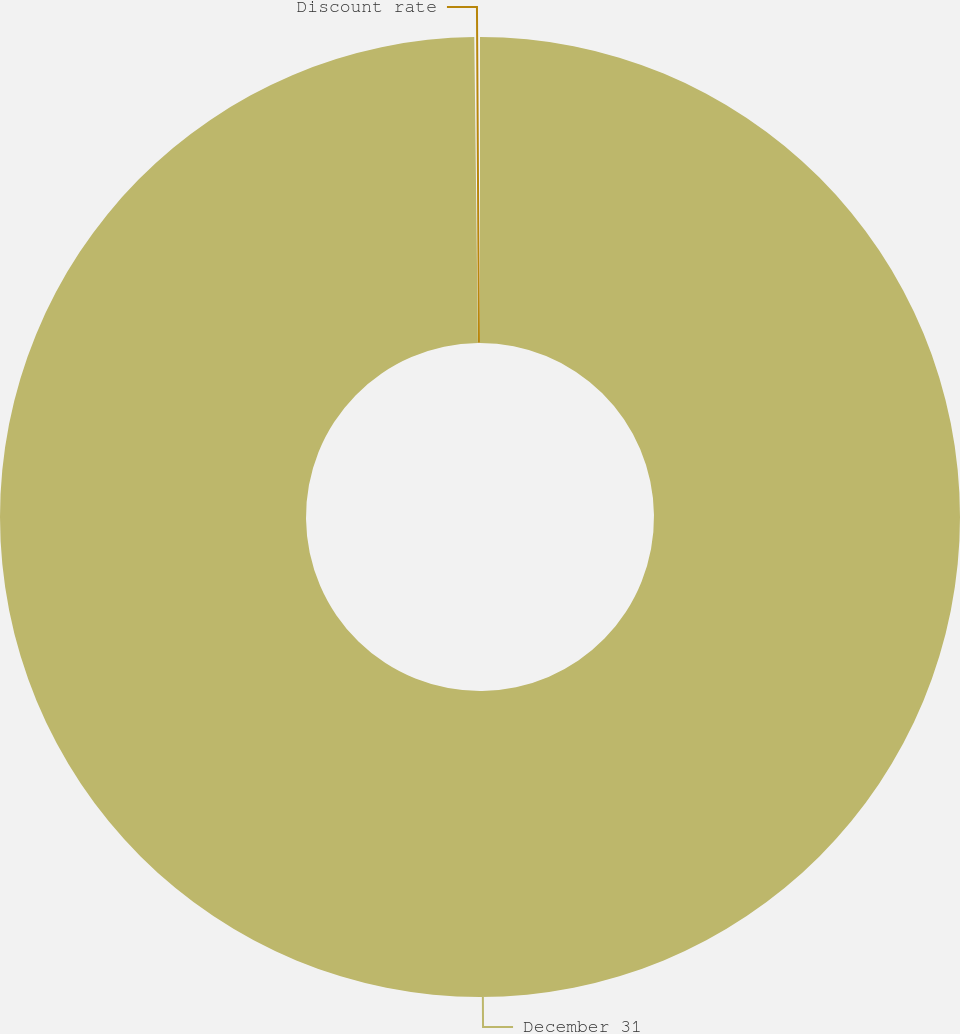<chart> <loc_0><loc_0><loc_500><loc_500><pie_chart><fcel>December 31<fcel>Discount rate<nl><fcel>99.81%<fcel>0.19%<nl></chart> 